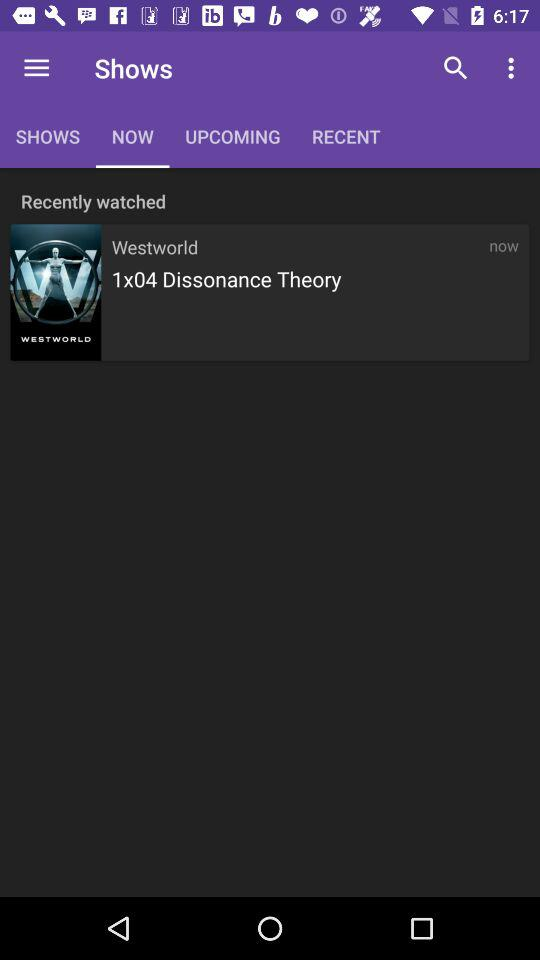How many episodes have I watched of Westworld?
Answer the question using a single word or phrase. 1 